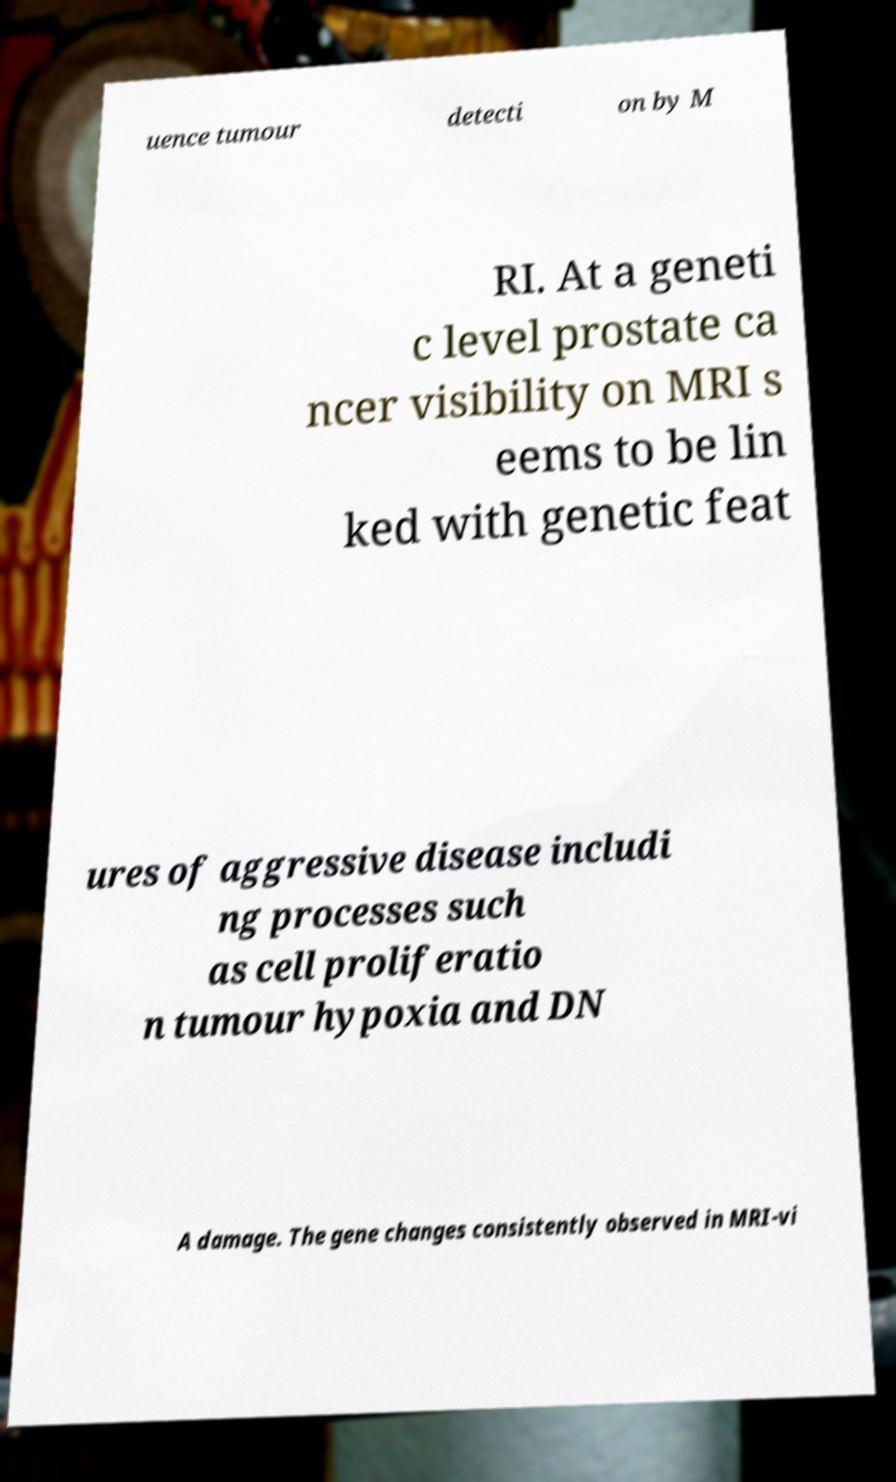I need the written content from this picture converted into text. Can you do that? uence tumour detecti on by M RI. At a geneti c level prostate ca ncer visibility on MRI s eems to be lin ked with genetic feat ures of aggressive disease includi ng processes such as cell proliferatio n tumour hypoxia and DN A damage. The gene changes consistently observed in MRI-vi 